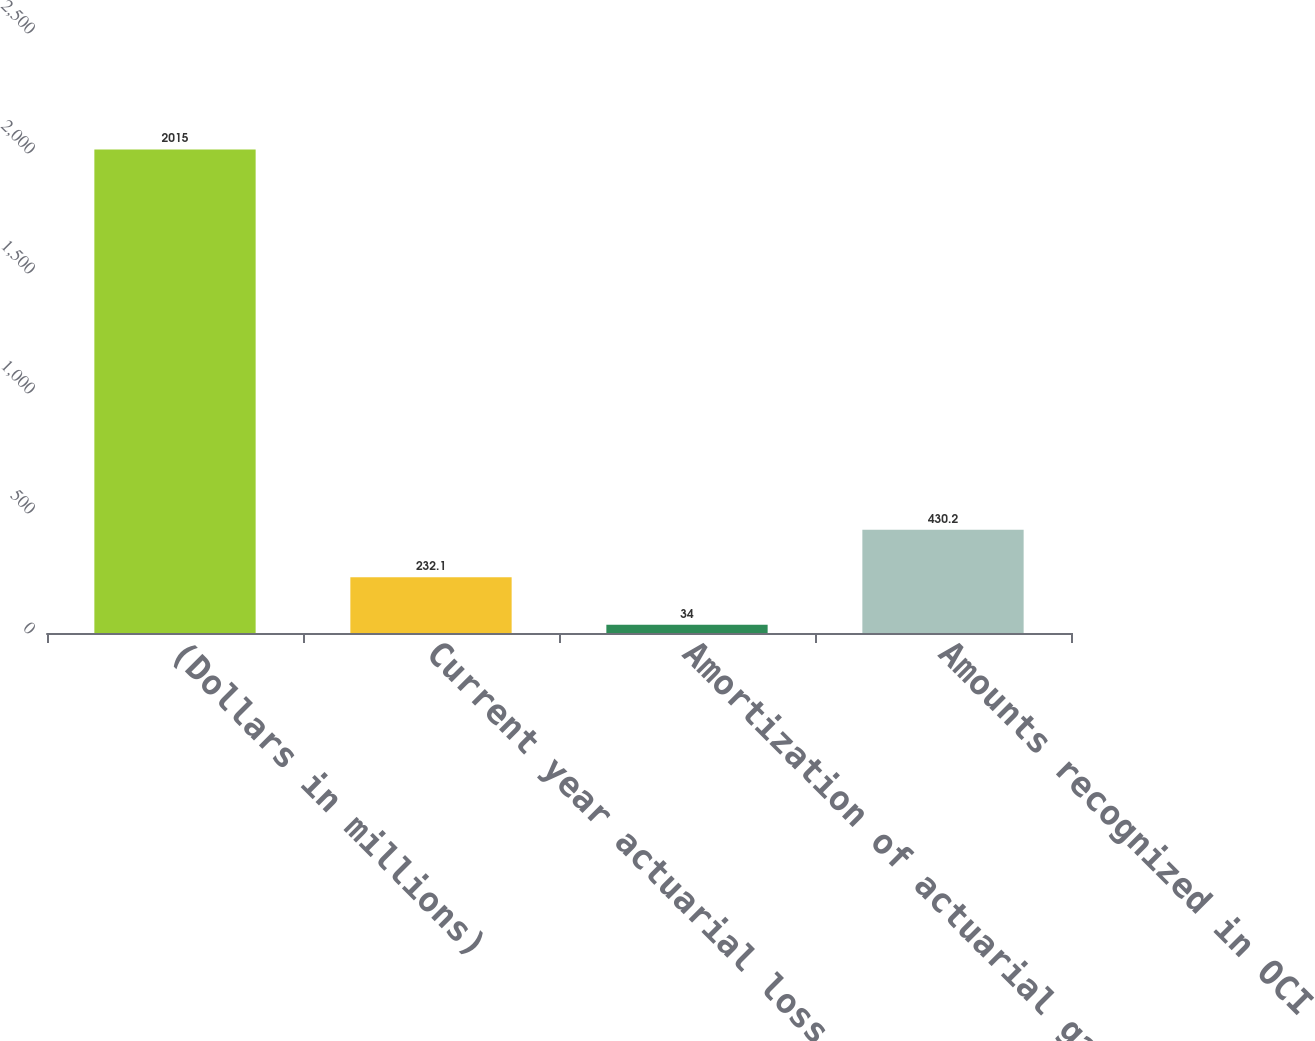Convert chart to OTSL. <chart><loc_0><loc_0><loc_500><loc_500><bar_chart><fcel>(Dollars in millions)<fcel>Current year actuarial loss<fcel>Amortization of actuarial gain<fcel>Amounts recognized in OCI<nl><fcel>2015<fcel>232.1<fcel>34<fcel>430.2<nl></chart> 